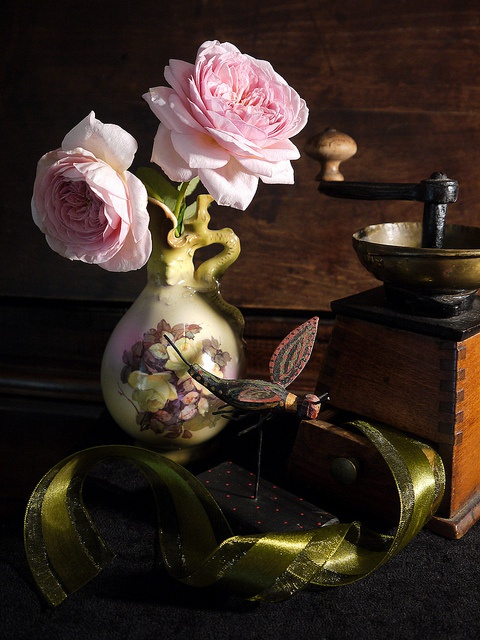Describe the objects in this image and their specific colors. I can see potted plant in black, lightgray, lightpink, and gray tones and vase in black, olive, gray, and tan tones in this image. 